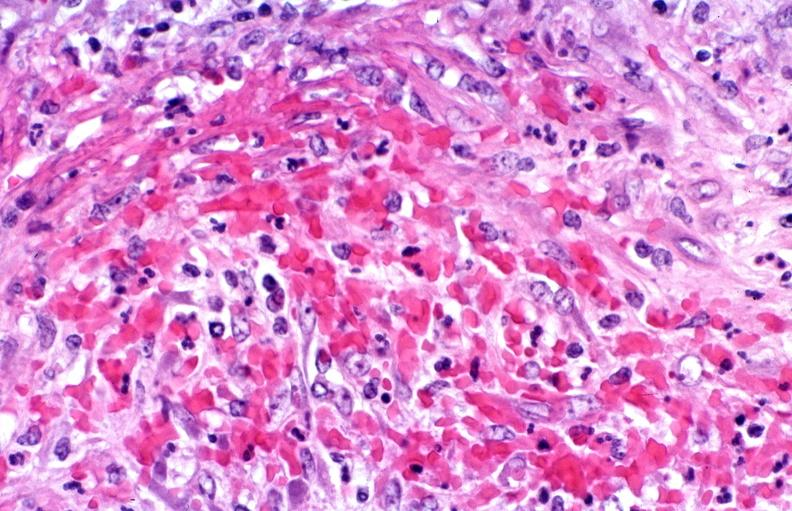does macerated stillborn show polyarteritis nodosa?
Answer the question using a single word or phrase. No 